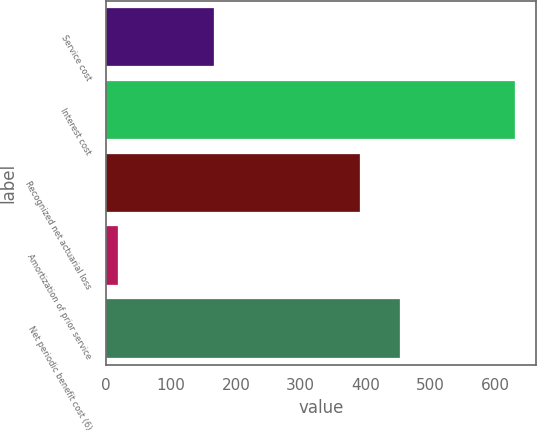Convert chart. <chart><loc_0><loc_0><loc_500><loc_500><bar_chart><fcel>Service cost<fcel>Interest cost<fcel>Recognized net actuarial loss<fcel>Amortization of prior service<fcel>Net periodic benefit cost (6)<nl><fcel>166<fcel>630<fcel>391<fcel>18<fcel>452.2<nl></chart> 